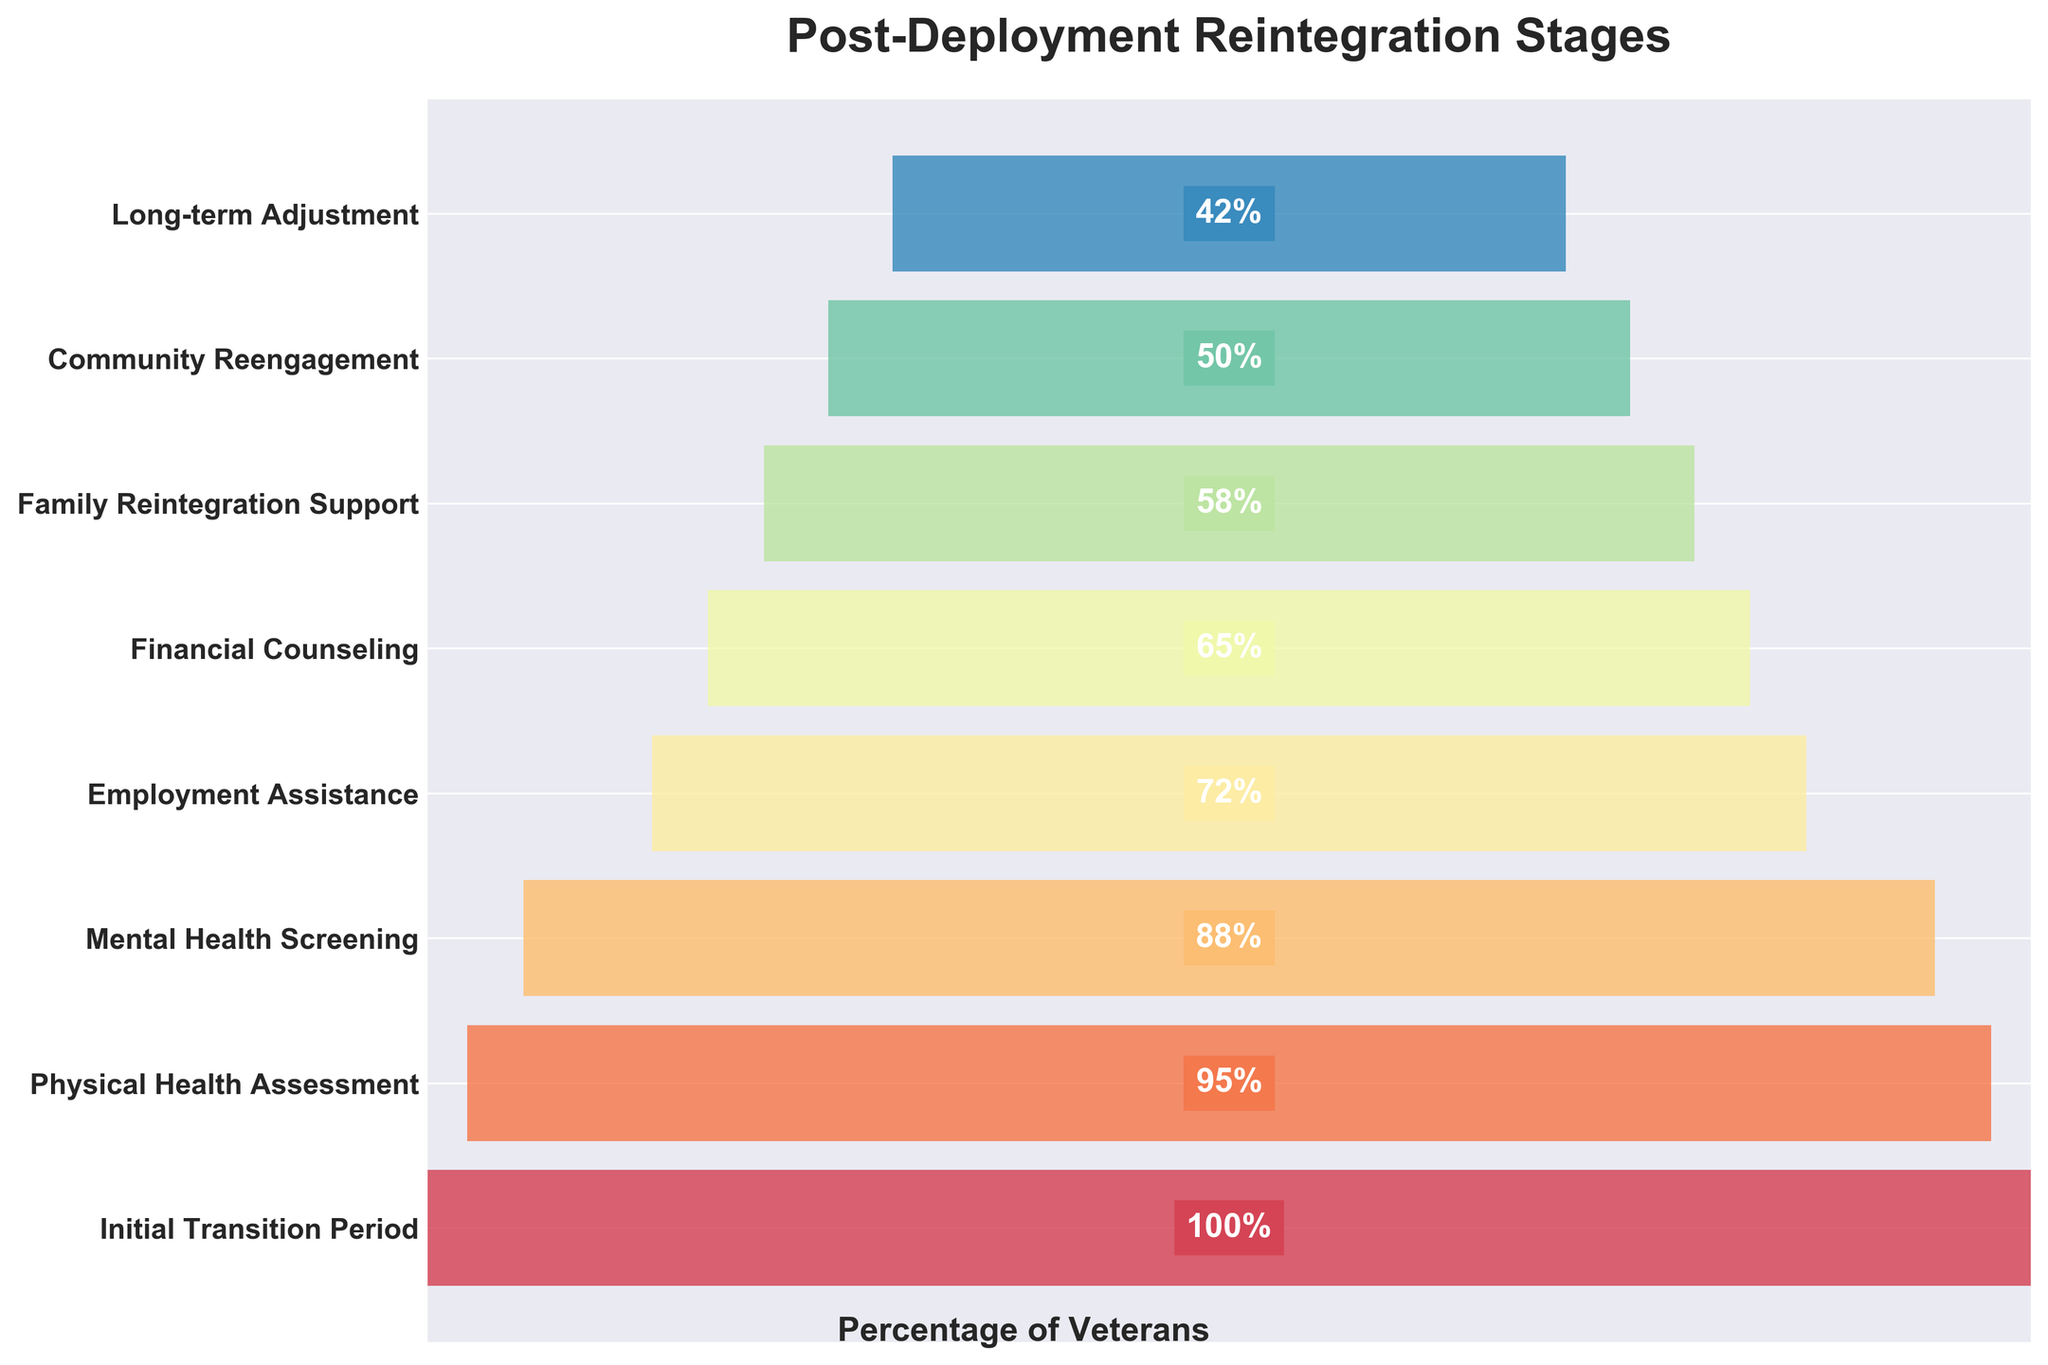What is the title of the figure? The title of the figure is displayed at the top of the plot in bold text. It provides an overall description of the content.
Answer: Post-Deployment Reintegration Stages What stage has the highest percentage of veterans completing it? The stage with the highest percentage is the first one in the funnel chart, which has both the widest bar and 100% indicated within it.
Answer: Initial Transition Period How many stages are listed in the chart? The y-axis lists each stage from top to bottom, and by counting them, you can determine the number of stages. Here, there are 8 stages visible.
Answer: 8 What is the percentage difference between the Family Reintegration Support stage and the Long-term Adjustment stage? The percentage for Family Reintegration Support is 58%, and for Long-term Adjustment, it is 42%. Subtracting the latter from the former gives the difference: 58% - 42% = 16%.
Answer: 16% Which stage has a lower percentage completion: Employment Assistance or Mental Health Screening? By comparing the bars and the percentages, Employment Assistance is at 72% and Mental Health Screening is at 88%. Since 72% is less than 88%, Employment Assistance has a lower percentage.
Answer: Employment Assistance What visual feature shows the decrease in the completion percentage across stages? The funnel narrows from top to bottom, indicating a decrease in the width of bars which corresponds to the decreasing percentages of veteran completion for each stage.
Answer: Narrowing of the funnel How much more is the percentage completion of Physical Health Assessment compared to Community Reengagement? The percentage for Physical Health Assessment is 95%, and for Community Reengagement, it is 50%. The difference is 95% - 50% = 45%.
Answer: 45% Is the drop between stages substantial or gradual based on the visualization? The width of the bars and the associated percentages show the change between stages. Most stages show a gradual decline, but comparing each pair closely sometimes reveals substantial drops, e.g., between Employment Assistance (72%) and Financial Counseling (65%).
Answer: Gradual 